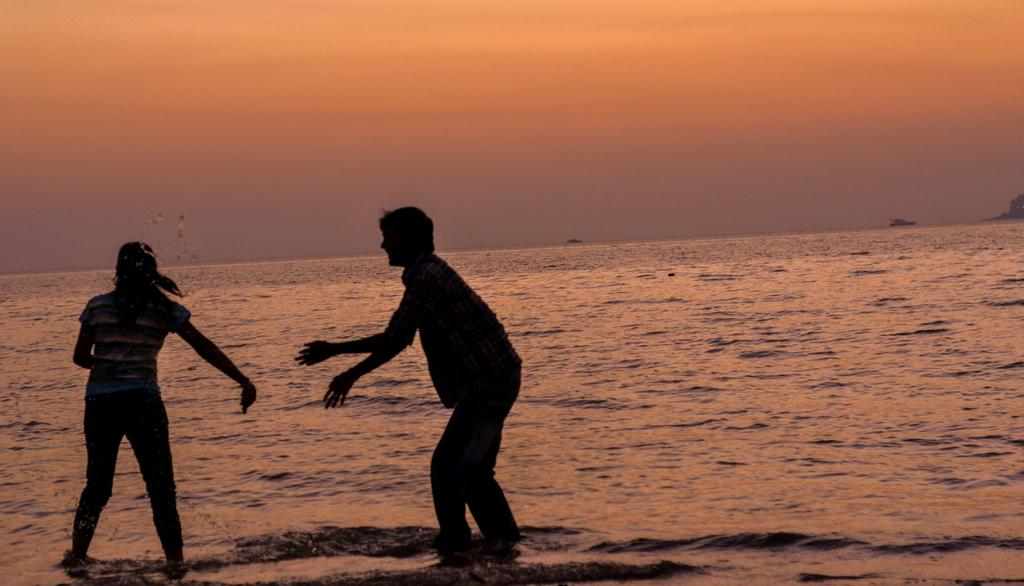How many people are in the image? There are two people in the image. What are the people doing in the image? The people are standing on the water and playing with the water. What is the position of the sun in the image? The sun is setting in the image. What type of drum can be heard in the image? There is no drum present in the image, and therefore no sound can be heard. 